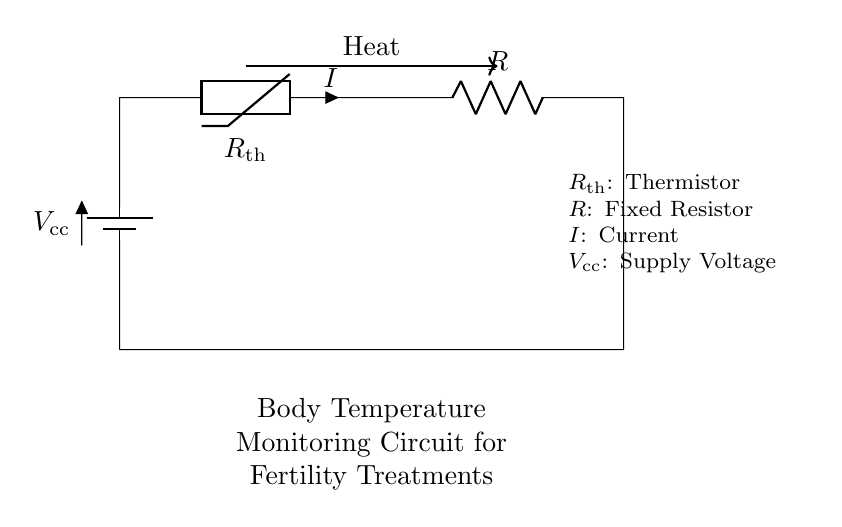What type of circuit is shown? This circuit is a series circuit because it features components connected in a single path, so the same current flows through each component.
Answer: series What components are present in the circuit? The circuit contains a thermistor and a fixed resistor as its main components. A battery is also included as the power source.
Answer: thermistor and resistor What does the thermistor measure? The thermistor is designed to measure temperature, and its resistance varies with changes in the body temperature.
Answer: temperature What is the role of the fixed resistor? The fixed resistor is used to limit the current flowing through the circuit, ensuring that the thermistor operates within its specified range.
Answer: limit current What happens to the current if the body temperature increases? As the body temperature increases, the resistance of the thermistor decreases, which increases the current flowing through the circuit.
Answer: increases What is the significance of this circuit for fertility treatments? This circuit helps monitor body temperature, which can provide valuable information for fertility treatments and pregnancy monitoring.
Answer: monitoring body temperature What is the supply voltage in this circuit? The supply voltage is represented as Vcc in the circuit, which is the voltage provided by the battery in order to power the circuit.
Answer: Vcc 